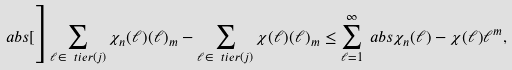Convert formula to latex. <formula><loc_0><loc_0><loc_500><loc_500>\ a b s [ \Big ] { \sum _ { \ell \in \ t i e r ( j ) } \chi _ { n } ( \ell ) ( \ell ) _ { m } - \sum _ { \ell \in \ t i e r ( j ) } \chi ( \ell ) ( \ell ) _ { m } } & \leq \sum _ { \ell = 1 } ^ { \infty } \ a b s { \chi _ { n } ( \ell ) - \chi ( \ell ) } \ell ^ { m } ,</formula> 